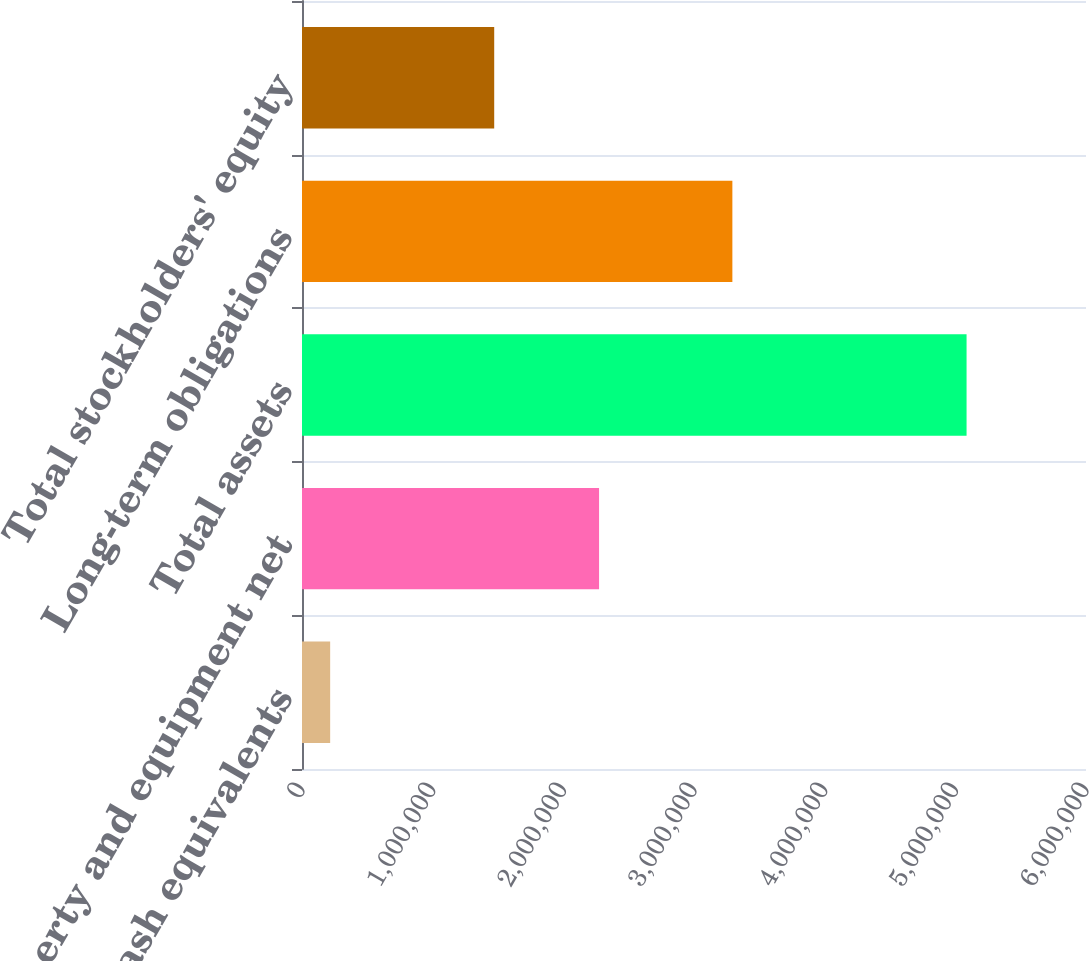<chart> <loc_0><loc_0><loc_500><loc_500><bar_chart><fcel>Cash and cash equivalents<fcel>Property and equipment net<fcel>Total assets<fcel>Long-term obligations<fcel>Total stockholders' equity<nl><fcel>215557<fcel>2.27336e+06<fcel>5.08597e+06<fcel>3.29361e+06<fcel>1.47095e+06<nl></chart> 